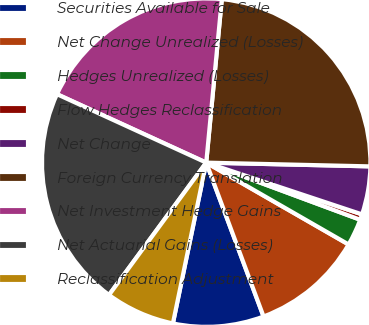<chart> <loc_0><loc_0><loc_500><loc_500><pie_chart><fcel>Securities Available for Sale<fcel>Net Change Unrealized (Losses)<fcel>Hedges Unrealized (Losses)<fcel>Flow Hedges Reclassification<fcel>Net Change<fcel>Foreign Currency Translation<fcel>Net Investment Hedge Gains<fcel>Net Actuarial Gains (Losses)<fcel>Reclassification Adjustment<nl><fcel>8.93%<fcel>11.02%<fcel>2.65%<fcel>0.55%<fcel>4.74%<fcel>23.85%<fcel>19.67%<fcel>21.76%<fcel>6.83%<nl></chart> 